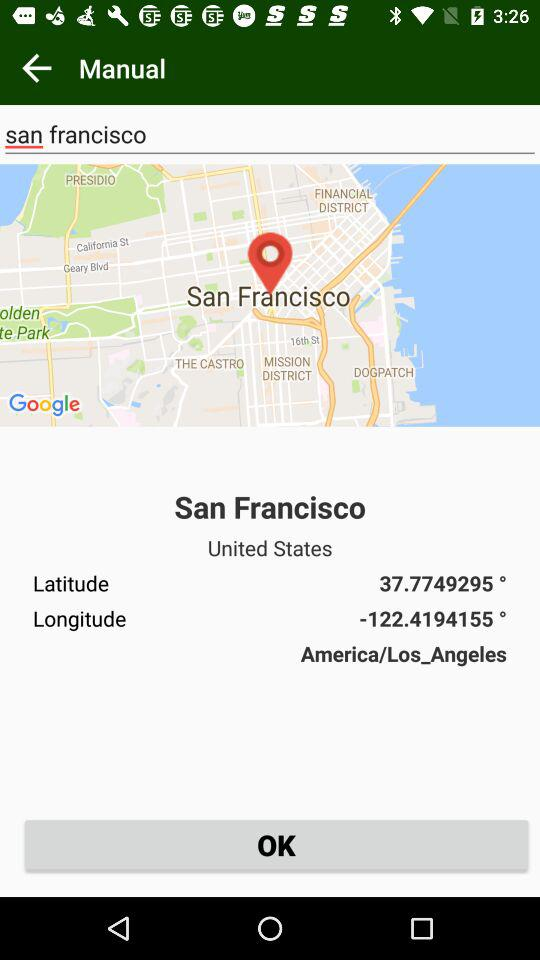What's the latitude of San Francisco? The latitude is 37.7749295 °. 